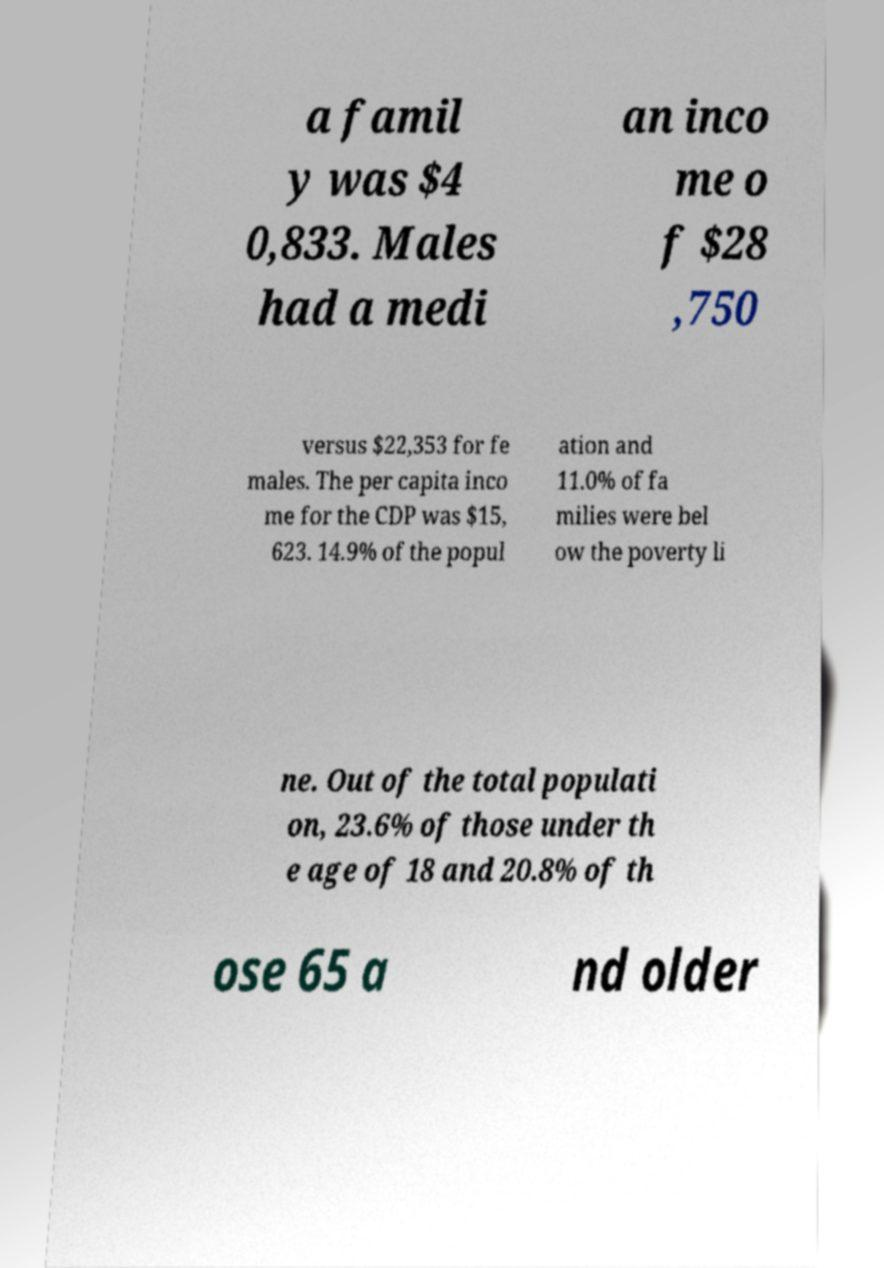Please identify and transcribe the text found in this image. a famil y was $4 0,833. Males had a medi an inco me o f $28 ,750 versus $22,353 for fe males. The per capita inco me for the CDP was $15, 623. 14.9% of the popul ation and 11.0% of fa milies were bel ow the poverty li ne. Out of the total populati on, 23.6% of those under th e age of 18 and 20.8% of th ose 65 a nd older 